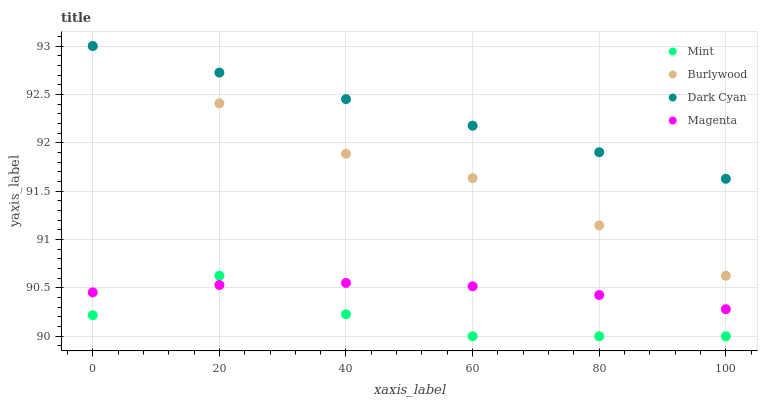Does Mint have the minimum area under the curve?
Answer yes or no. Yes. Does Dark Cyan have the maximum area under the curve?
Answer yes or no. Yes. Does Magenta have the minimum area under the curve?
Answer yes or no. No. Does Magenta have the maximum area under the curve?
Answer yes or no. No. Is Dark Cyan the smoothest?
Answer yes or no. Yes. Is Mint the roughest?
Answer yes or no. Yes. Is Magenta the smoothest?
Answer yes or no. No. Is Magenta the roughest?
Answer yes or no. No. Does Mint have the lowest value?
Answer yes or no. Yes. Does Magenta have the lowest value?
Answer yes or no. No. Does Dark Cyan have the highest value?
Answer yes or no. Yes. Does Magenta have the highest value?
Answer yes or no. No. Is Mint less than Burlywood?
Answer yes or no. Yes. Is Burlywood greater than Magenta?
Answer yes or no. Yes. Does Mint intersect Magenta?
Answer yes or no. Yes. Is Mint less than Magenta?
Answer yes or no. No. Is Mint greater than Magenta?
Answer yes or no. No. Does Mint intersect Burlywood?
Answer yes or no. No. 